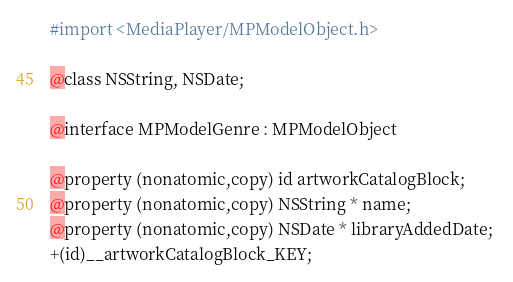<code> <loc_0><loc_0><loc_500><loc_500><_C_>
#import <MediaPlayer/MPModelObject.h>

@class NSString, NSDate;

@interface MPModelGenre : MPModelObject

@property (nonatomic,copy) id artworkCatalogBlock; 
@property (nonatomic,copy) NSString * name; 
@property (nonatomic,copy) NSDate * libraryAddedDate; 
+(id)__artworkCatalogBlock_KEY;</code> 